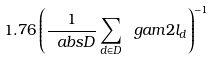<formula> <loc_0><loc_0><loc_500><loc_500>1 . 7 6 \left ( \frac { 1 } { \ a b s { D } } \sum _ { d \in D } \ g a m { 2 } l _ { d } \right ) ^ { - 1 }</formula> 